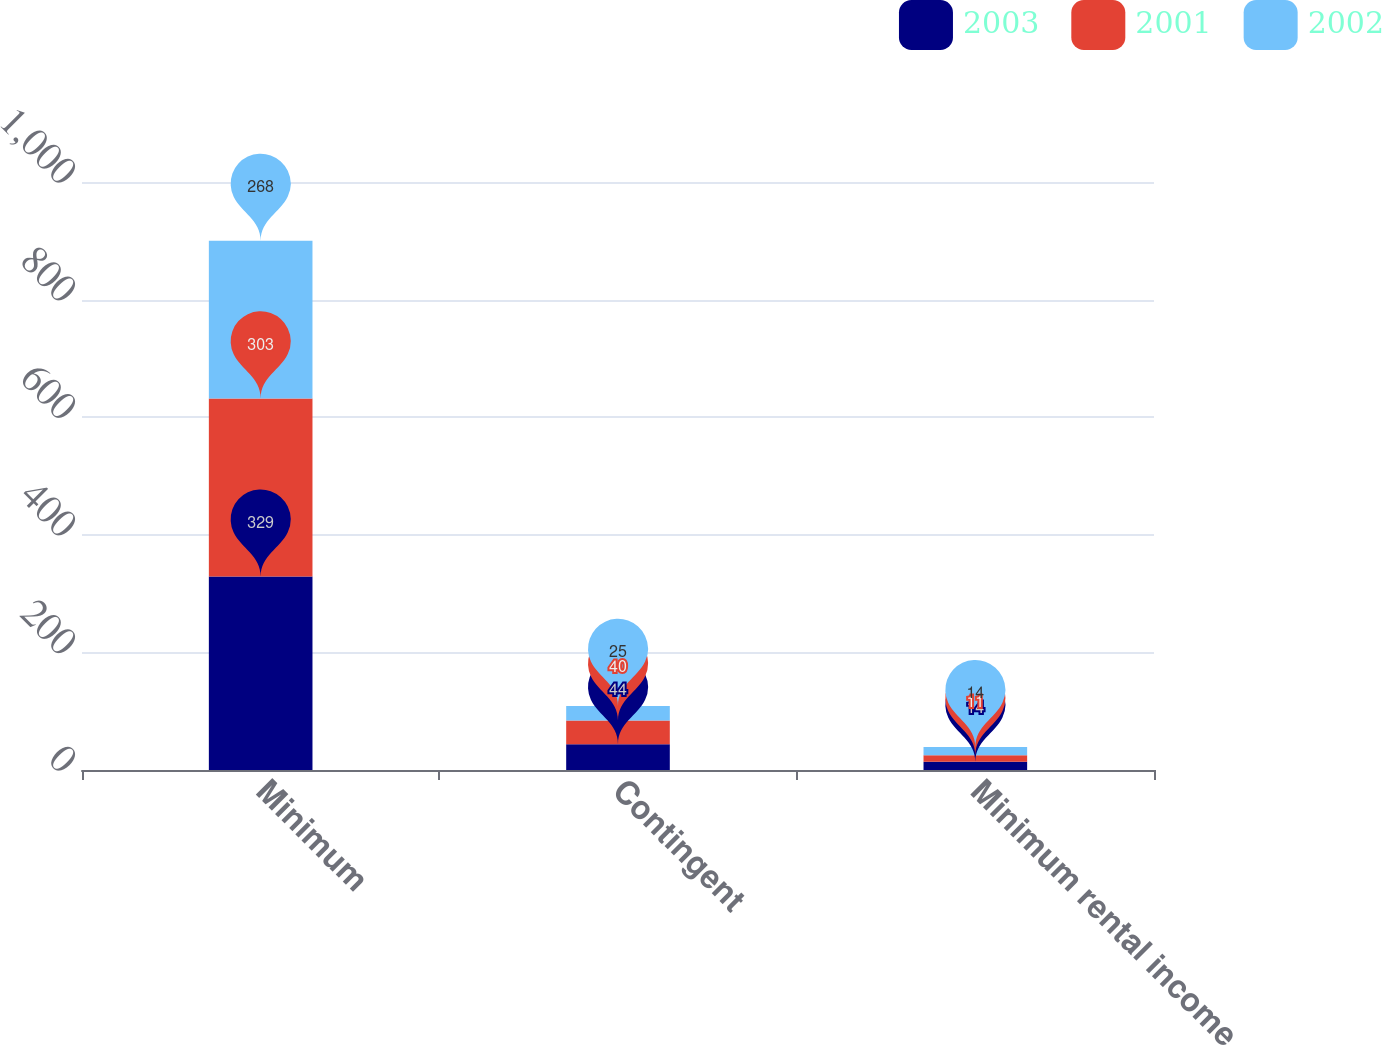Convert chart to OTSL. <chart><loc_0><loc_0><loc_500><loc_500><stacked_bar_chart><ecel><fcel>Minimum<fcel>Contingent<fcel>Minimum rental income<nl><fcel>2003<fcel>329<fcel>44<fcel>14<nl><fcel>2001<fcel>303<fcel>40<fcel>11<nl><fcel>2002<fcel>268<fcel>25<fcel>14<nl></chart> 